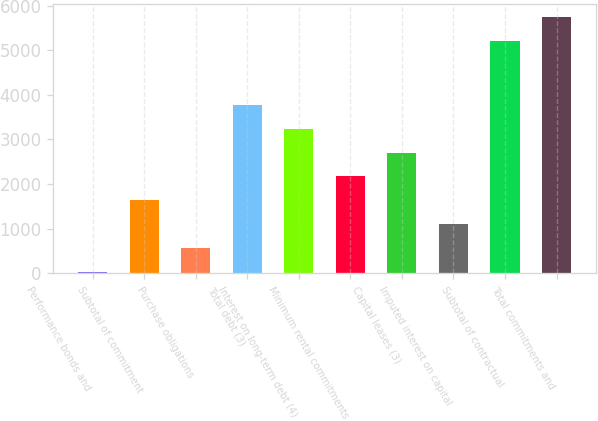<chart> <loc_0><loc_0><loc_500><loc_500><bar_chart><fcel>Performance bonds and<fcel>Subtotal of commitment<fcel>Purchase obligations<fcel>Total debt (3)<fcel>Interest on long-term debt (4)<fcel>Minimum rental commitments<fcel>Capital leases (3)<fcel>Imputed interest on capital<fcel>Subtotal of contractual<fcel>Total commitments and<nl><fcel>36<fcel>1637.4<fcel>569.8<fcel>3772.6<fcel>3238.8<fcel>2171.2<fcel>2705<fcel>1103.6<fcel>5204<fcel>5737.8<nl></chart> 